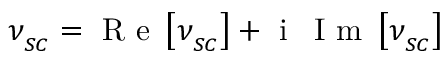Convert formula to latex. <formula><loc_0><loc_0><loc_500><loc_500>\nu _ { _ { S C } } = R e \left [ \nu _ { _ { S C } } \right ] + i \, I m \left [ \nu _ { _ { S C } } \right ]</formula> 